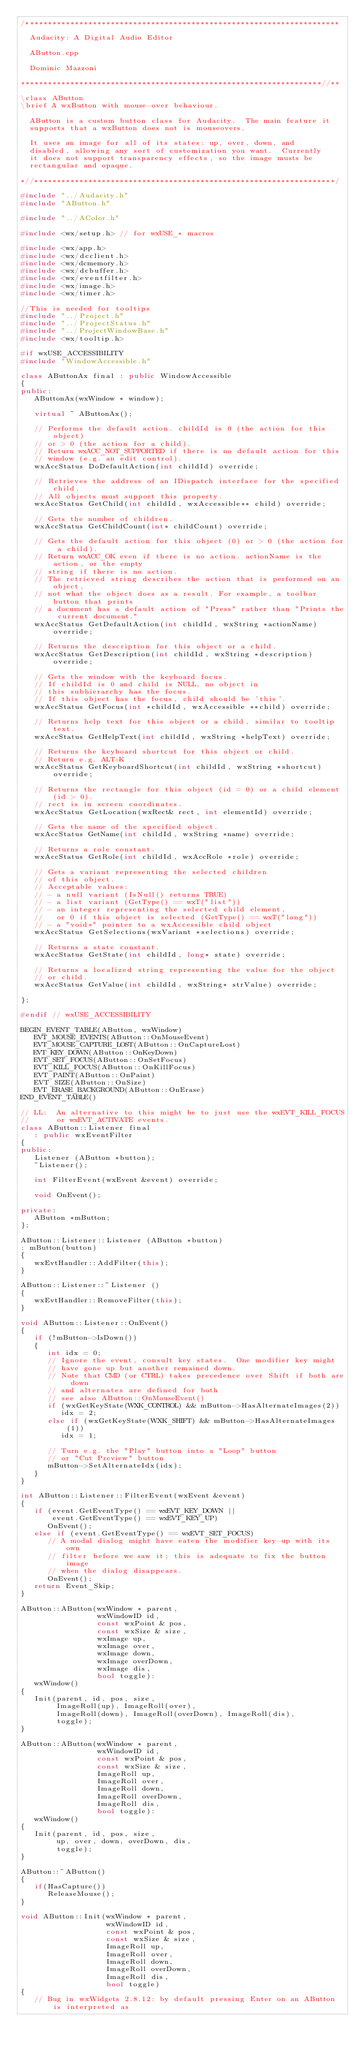<code> <loc_0><loc_0><loc_500><loc_500><_C++_>/**********************************************************************

  Audacity: A Digital Audio Editor

  AButton.cpp

  Dominic Mazzoni

*******************************************************************//**

\class AButton
\brief A wxButton with mouse-over behaviour.

  AButton is a custom button class for Audacity.  The main feature it
  supports that a wxButton does not is mouseovers.

  It uses an image for all of its states: up, over, down, and
  disabled, allowing any sort of customization you want.  Currently
  it does not support transparency effects, so the image musts be
  rectangular and opaque.

*//*******************************************************************/

#include "../Audacity.h"
#include "AButton.h"

#include "../AColor.h"

#include <wx/setup.h> // for wxUSE_* macros

#include <wx/app.h>
#include <wx/dcclient.h>
#include <wx/dcmemory.h>
#include <wx/dcbuffer.h>
#include <wx/eventfilter.h>
#include <wx/image.h>
#include <wx/timer.h>

//This is needed for tooltips
#include "../Project.h"
#include "../ProjectStatus.h"
#include "../ProjectWindowBase.h"
#include <wx/tooltip.h>

#if wxUSE_ACCESSIBILITY
#include "WindowAccessible.h"

class AButtonAx final : public WindowAccessible
{
public:
   AButtonAx(wxWindow * window);

   virtual ~ AButtonAx();

   // Performs the default action. childId is 0 (the action for this object)
   // or > 0 (the action for a child).
   // Return wxACC_NOT_SUPPORTED if there is no default action for this
   // window (e.g. an edit control).
   wxAccStatus DoDefaultAction(int childId) override;

   // Retrieves the address of an IDispatch interface for the specified child.
   // All objects must support this property.
   wxAccStatus GetChild(int childId, wxAccessible** child) override;

   // Gets the number of children.
   wxAccStatus GetChildCount(int* childCount) override;

   // Gets the default action for this object (0) or > 0 (the action for a child).
   // Return wxACC_OK even if there is no action. actionName is the action, or the empty
   // string if there is no action.
   // The retrieved string describes the action that is performed on an object,
   // not what the object does as a result. For example, a toolbar button that prints
   // a document has a default action of "Press" rather than "Prints the current document."
   wxAccStatus GetDefaultAction(int childId, wxString *actionName) override;

   // Returns the description for this object or a child.
   wxAccStatus GetDescription(int childId, wxString *description) override;

   // Gets the window with the keyboard focus.
   // If childId is 0 and child is NULL, no object in
   // this subhierarchy has the focus.
   // If this object has the focus, child should be 'this'.
   wxAccStatus GetFocus(int *childId, wxAccessible **child) override;

   // Returns help text for this object or a child, similar to tooltip text.
   wxAccStatus GetHelpText(int childId, wxString *helpText) override;

   // Returns the keyboard shortcut for this object or child.
   // Return e.g. ALT+K
   wxAccStatus GetKeyboardShortcut(int childId, wxString *shortcut) override;

   // Returns the rectangle for this object (id = 0) or a child element (id > 0).
   // rect is in screen coordinates.
   wxAccStatus GetLocation(wxRect& rect, int elementId) override;

   // Gets the name of the specified object.
   wxAccStatus GetName(int childId, wxString *name) override;

   // Returns a role constant.
   wxAccStatus GetRole(int childId, wxAccRole *role) override;

   // Gets a variant representing the selected children
   // of this object.
   // Acceptable values:
   // - a null variant (IsNull() returns TRUE)
   // - a list variant (GetType() == wxT("list"))
   // - an integer representing the selected child element,
   //   or 0 if this object is selected (GetType() == wxT("long"))
   // - a "void*" pointer to a wxAccessible child object
   wxAccStatus GetSelections(wxVariant *selections) override;

   // Returns a state constant.
   wxAccStatus GetState(int childId, long* state) override;

   // Returns a localized string representing the value for the object
   // or child.
   wxAccStatus GetValue(int childId, wxString* strValue) override;

};

#endif // wxUSE_ACCESSIBILITY

BEGIN_EVENT_TABLE(AButton, wxWindow)
   EVT_MOUSE_EVENTS(AButton::OnMouseEvent)
   EVT_MOUSE_CAPTURE_LOST(AButton::OnCaptureLost)
   EVT_KEY_DOWN(AButton::OnKeyDown)
   EVT_SET_FOCUS(AButton::OnSetFocus)
   EVT_KILL_FOCUS(AButton::OnKillFocus)
   EVT_PAINT(AButton::OnPaint)
   EVT_SIZE(AButton::OnSize)
   EVT_ERASE_BACKGROUND(AButton::OnErase)
END_EVENT_TABLE()

// LL:  An alternative to this might be to just use the wxEVT_KILL_FOCUS
//      or wxEVT_ACTIVATE events.
class AButton::Listener final
   : public wxEventFilter
{
public:
   Listener (AButton *button);
   ~Listener();

   int FilterEvent(wxEvent &event) override;

   void OnEvent();

private:
   AButton *mButton;
};

AButton::Listener::Listener (AButton *button)
: mButton(button)
{
   wxEvtHandler::AddFilter(this);
}

AButton::Listener::~Listener ()
{
   wxEvtHandler::RemoveFilter(this);
}

void AButton::Listener::OnEvent()
{
   if (!mButton->IsDown())
   {
      int idx = 0;
      // Ignore the event, consult key states.  One modifier key might
      // have gone up but another remained down.
      // Note that CMD (or CTRL) takes precedence over Shift if both are down
      // and alternates are defined for both
      // see also AButton::OnMouseEvent()
      if (wxGetKeyState(WXK_CONTROL) && mButton->HasAlternateImages(2))
         idx = 2;
      else if (wxGetKeyState(WXK_SHIFT) && mButton->HasAlternateImages(1))
         idx = 1;

      // Turn e.g. the "Play" button into a "Loop" button
      // or "Cut Preview" button
      mButton->SetAlternateIdx(idx);
   }
}

int AButton::Listener::FilterEvent(wxEvent &event)
{
   if (event.GetEventType() == wxEVT_KEY_DOWN ||
       event.GetEventType() == wxEVT_KEY_UP)
      OnEvent();
   else if (event.GetEventType() == wxEVT_SET_FOCUS)
      // A modal dialog might have eaten the modifier key-up with its own
      // filter before we saw it; this is adequate to fix the button image
      // when the dialog disappears.
      OnEvent();
   return Event_Skip;
}

AButton::AButton(wxWindow * parent,
                 wxWindowID id,
                 const wxPoint & pos,
                 const wxSize & size,
                 wxImage up,
                 wxImage over,
                 wxImage down,
                 wxImage overDown,
                 wxImage dis,
                 bool toggle):
   wxWindow()
{
   Init(parent, id, pos, size,
        ImageRoll(up), ImageRoll(over),
        ImageRoll(down), ImageRoll(overDown), ImageRoll(dis),
        toggle);
}

AButton::AButton(wxWindow * parent,
                 wxWindowID id,
                 const wxPoint & pos,
                 const wxSize & size,
                 ImageRoll up,
                 ImageRoll over,
                 ImageRoll down,
                 ImageRoll overDown,
                 ImageRoll dis,
                 bool toggle):
   wxWindow()
{
   Init(parent, id, pos, size,
        up, over, down, overDown, dis,
        toggle);
}

AButton::~AButton()
{
   if(HasCapture())
      ReleaseMouse();
}

void AButton::Init(wxWindow * parent,
                   wxWindowID id,
                   const wxPoint & pos,
                   const wxSize & size,
                   ImageRoll up,
                   ImageRoll over,
                   ImageRoll down,
                   ImageRoll overDown,
                   ImageRoll dis,
                   bool toggle)
{
   // Bug in wxWidgets 2.8.12: by default pressing Enter on an AButton is interpreted as</code> 